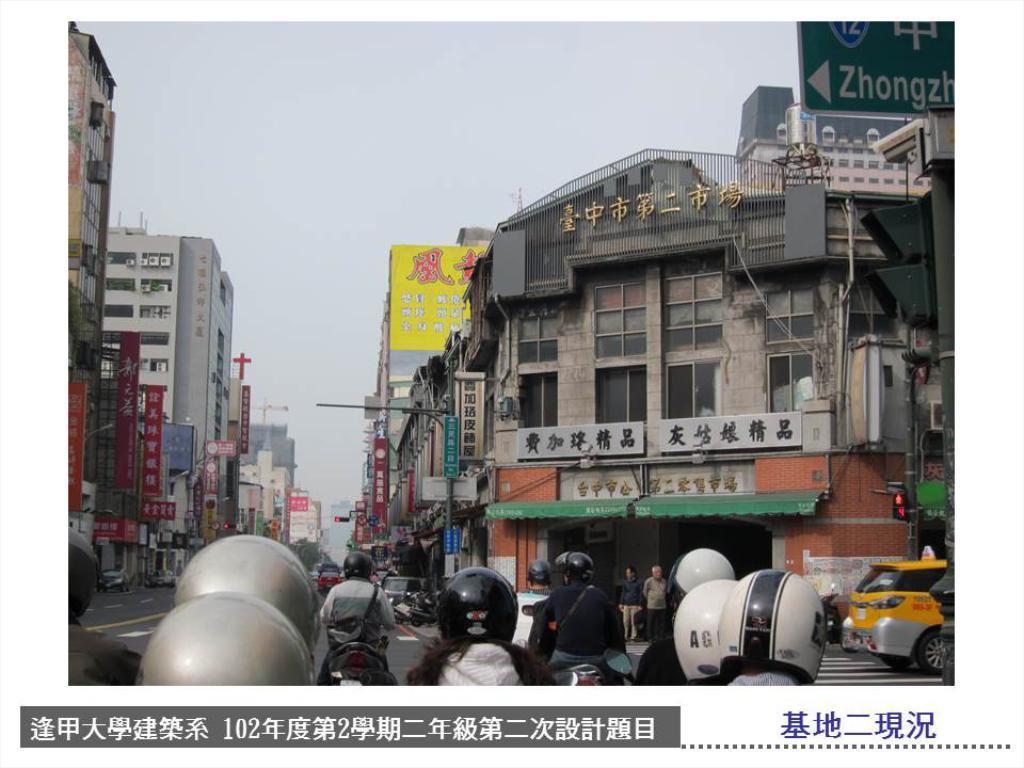How would you summarize this image in a sentence or two? In this picture we can see some people with the helmets and in front of the people, there are vehicles on the road and some people are standing and there are poles with directional board and traffic signals. Behind the people there are buildings, boards, hoarding, banners and a sky. On the image there is a watermark. 